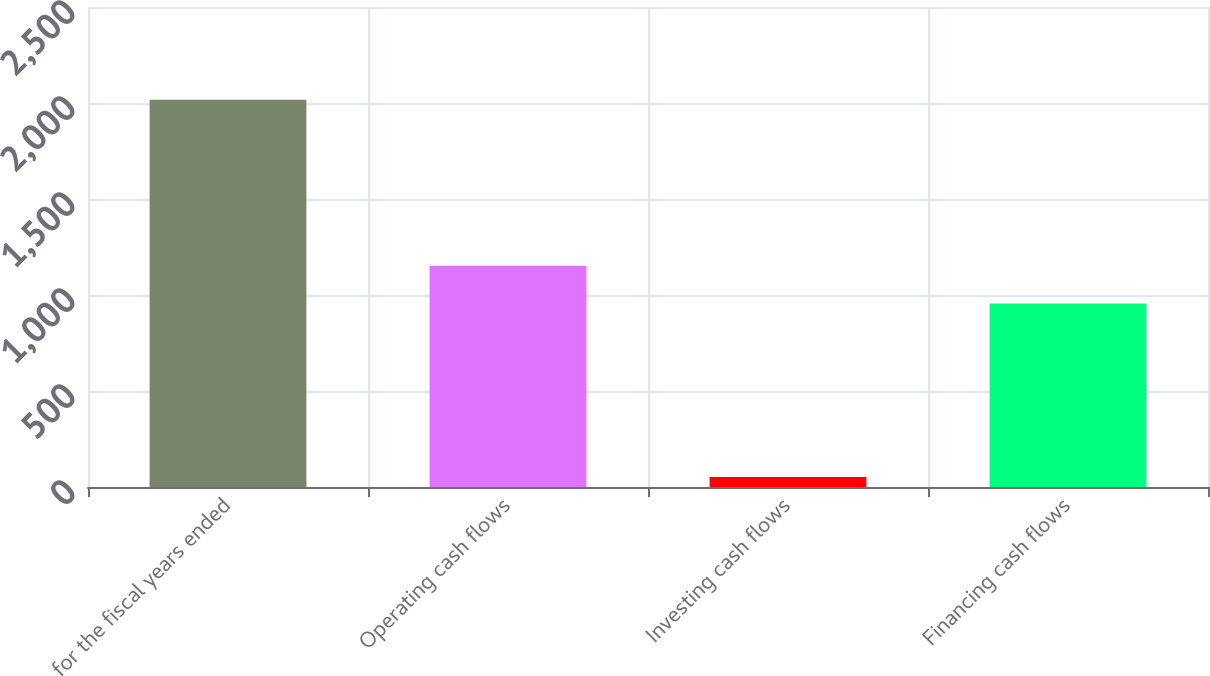Convert chart. <chart><loc_0><loc_0><loc_500><loc_500><bar_chart><fcel>for the fiscal years ended<fcel>Operating cash flows<fcel>Investing cash flows<fcel>Financing cash flows<nl><fcel>2017<fcel>1152.5<fcel>52<fcel>956<nl></chart> 